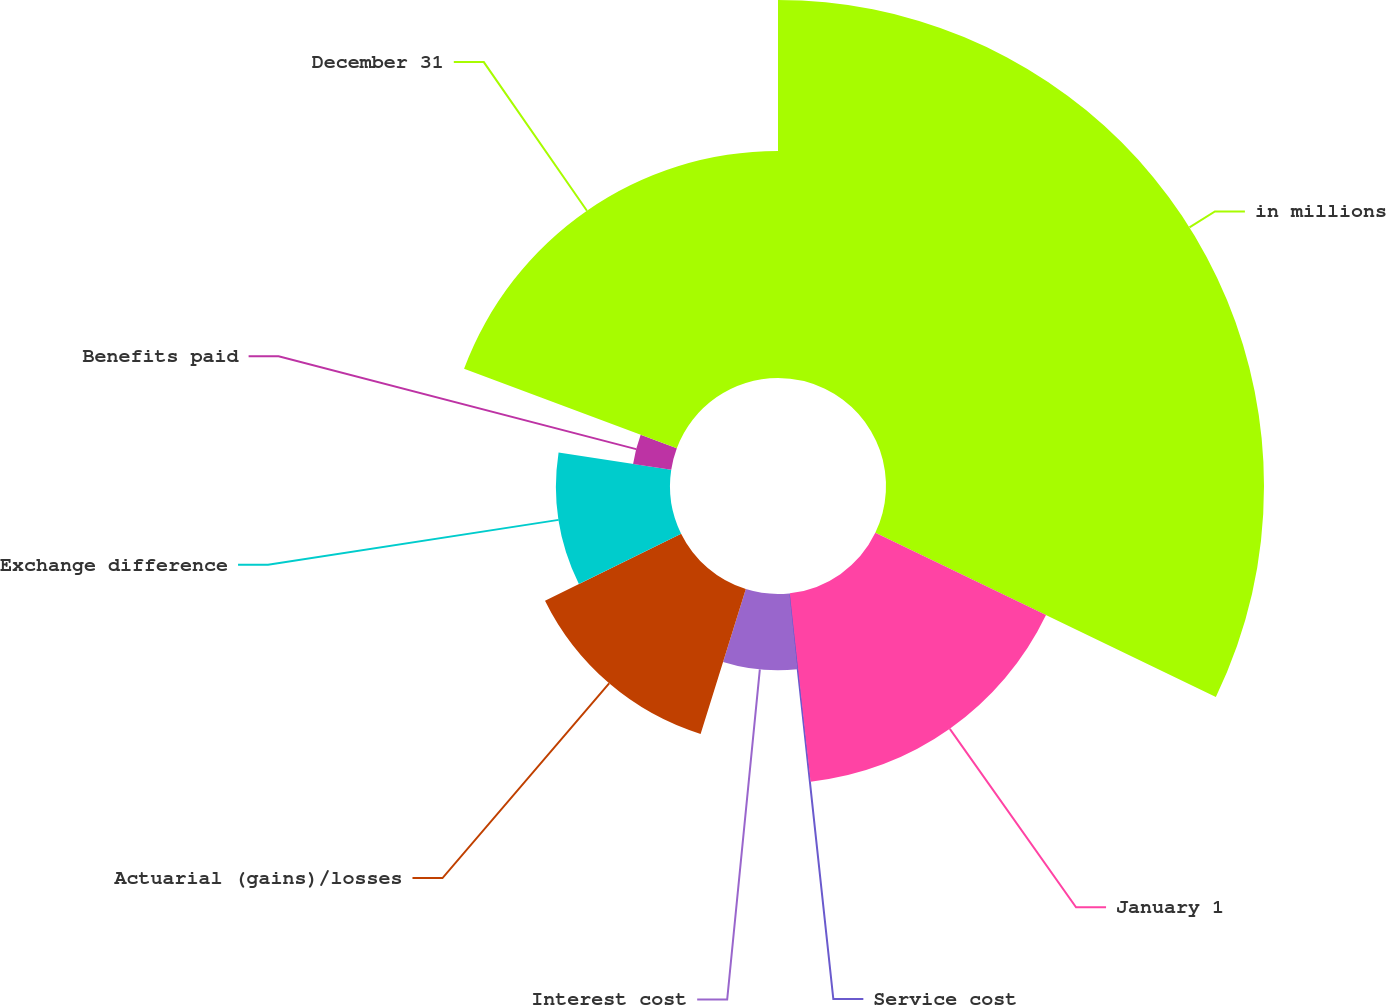Convert chart to OTSL. <chart><loc_0><loc_0><loc_500><loc_500><pie_chart><fcel>in millions<fcel>January 1<fcel>Service cost<fcel>Interest cost<fcel>Actuarial (gains)/losses<fcel>Exchange difference<fcel>Benefits paid<fcel>December 31<nl><fcel>32.14%<fcel>16.11%<fcel>0.07%<fcel>6.49%<fcel>12.9%<fcel>9.69%<fcel>3.28%<fcel>19.31%<nl></chart> 